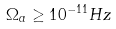Convert formula to latex. <formula><loc_0><loc_0><loc_500><loc_500>\Omega _ { a } \geq 1 0 ^ { - 1 1 } H z</formula> 